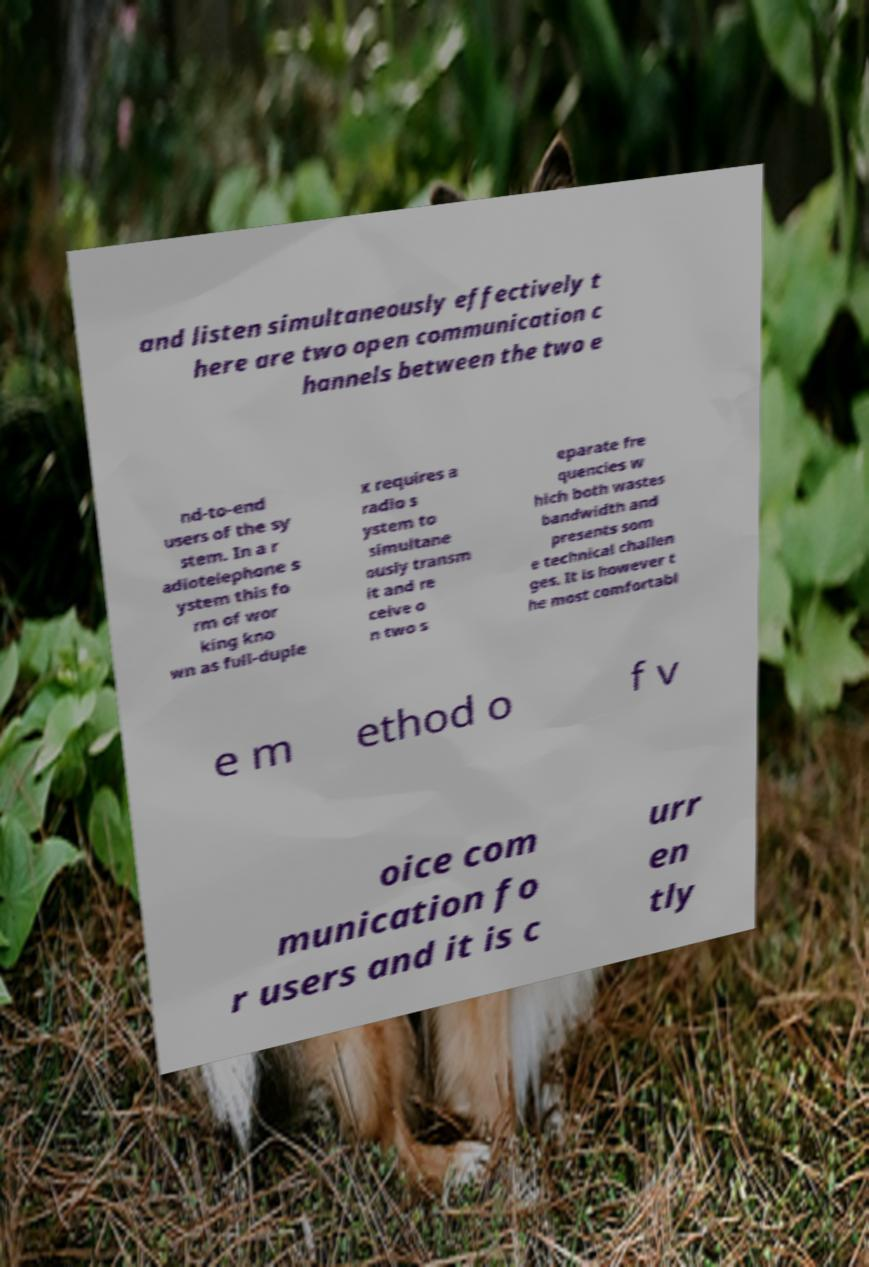Can you accurately transcribe the text from the provided image for me? and listen simultaneously effectively t here are two open communication c hannels between the two e nd-to-end users of the sy stem. In a r adiotelephone s ystem this fo rm of wor king kno wn as full-duple x requires a radio s ystem to simultane ously transm it and re ceive o n two s eparate fre quencies w hich both wastes bandwidth and presents som e technical challen ges. It is however t he most comfortabl e m ethod o f v oice com munication fo r users and it is c urr en tly 